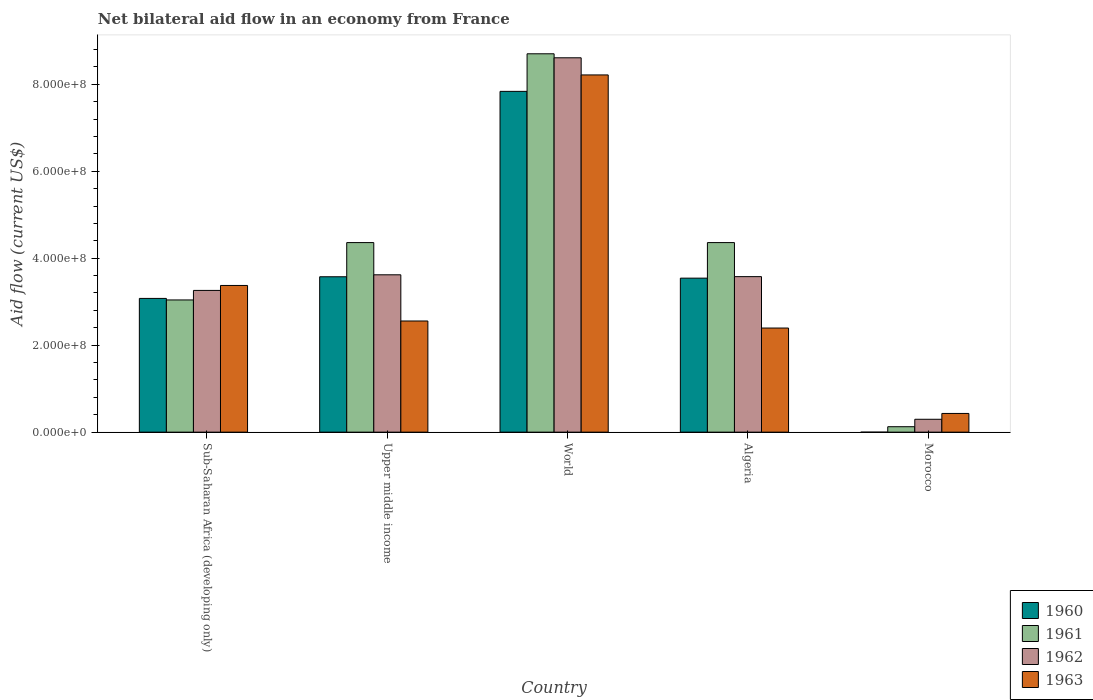How many groups of bars are there?
Offer a terse response. 5. Are the number of bars per tick equal to the number of legend labels?
Provide a short and direct response. No. Are the number of bars on each tick of the X-axis equal?
Provide a short and direct response. No. How many bars are there on the 1st tick from the left?
Provide a succinct answer. 4. How many bars are there on the 1st tick from the right?
Your answer should be compact. 3. What is the label of the 1st group of bars from the left?
Give a very brief answer. Sub-Saharan Africa (developing only). What is the net bilateral aid flow in 1960 in Morocco?
Provide a succinct answer. 0. Across all countries, what is the maximum net bilateral aid flow in 1962?
Give a very brief answer. 8.61e+08. Across all countries, what is the minimum net bilateral aid flow in 1963?
Provide a succinct answer. 4.30e+07. In which country was the net bilateral aid flow in 1960 maximum?
Offer a very short reply. World. What is the total net bilateral aid flow in 1963 in the graph?
Offer a terse response. 1.70e+09. What is the difference between the net bilateral aid flow in 1961 in Algeria and that in Upper middle income?
Give a very brief answer. 0. What is the difference between the net bilateral aid flow in 1961 in World and the net bilateral aid flow in 1960 in Algeria?
Your answer should be compact. 5.16e+08. What is the average net bilateral aid flow in 1962 per country?
Offer a very short reply. 3.87e+08. What is the difference between the net bilateral aid flow of/in 1963 and net bilateral aid flow of/in 1960 in World?
Your response must be concise. 3.78e+07. What is the ratio of the net bilateral aid flow in 1962 in Morocco to that in World?
Your answer should be very brief. 0.03. Is the net bilateral aid flow in 1963 in Algeria less than that in Morocco?
Offer a terse response. No. Is the difference between the net bilateral aid flow in 1963 in Algeria and Sub-Saharan Africa (developing only) greater than the difference between the net bilateral aid flow in 1960 in Algeria and Sub-Saharan Africa (developing only)?
Keep it short and to the point. No. What is the difference between the highest and the second highest net bilateral aid flow in 1961?
Offer a terse response. 4.34e+08. What is the difference between the highest and the lowest net bilateral aid flow in 1962?
Offer a very short reply. 8.31e+08. Is the sum of the net bilateral aid flow in 1962 in Algeria and Morocco greater than the maximum net bilateral aid flow in 1963 across all countries?
Provide a succinct answer. No. Is it the case that in every country, the sum of the net bilateral aid flow in 1963 and net bilateral aid flow in 1960 is greater than the net bilateral aid flow in 1962?
Offer a very short reply. Yes. How many bars are there?
Keep it short and to the point. 19. What is the difference between two consecutive major ticks on the Y-axis?
Your answer should be compact. 2.00e+08. Does the graph contain grids?
Ensure brevity in your answer.  No. What is the title of the graph?
Make the answer very short. Net bilateral aid flow in an economy from France. Does "1961" appear as one of the legend labels in the graph?
Your answer should be very brief. Yes. What is the label or title of the X-axis?
Ensure brevity in your answer.  Country. What is the Aid flow (current US$) in 1960 in Sub-Saharan Africa (developing only)?
Your answer should be very brief. 3.08e+08. What is the Aid flow (current US$) of 1961 in Sub-Saharan Africa (developing only)?
Your answer should be very brief. 3.04e+08. What is the Aid flow (current US$) in 1962 in Sub-Saharan Africa (developing only)?
Your answer should be very brief. 3.26e+08. What is the Aid flow (current US$) of 1963 in Sub-Saharan Africa (developing only)?
Offer a very short reply. 3.37e+08. What is the Aid flow (current US$) in 1960 in Upper middle income?
Offer a terse response. 3.57e+08. What is the Aid flow (current US$) in 1961 in Upper middle income?
Offer a terse response. 4.36e+08. What is the Aid flow (current US$) in 1962 in Upper middle income?
Offer a terse response. 3.62e+08. What is the Aid flow (current US$) in 1963 in Upper middle income?
Keep it short and to the point. 2.56e+08. What is the Aid flow (current US$) in 1960 in World?
Your response must be concise. 7.84e+08. What is the Aid flow (current US$) of 1961 in World?
Keep it short and to the point. 8.70e+08. What is the Aid flow (current US$) in 1962 in World?
Ensure brevity in your answer.  8.61e+08. What is the Aid flow (current US$) in 1963 in World?
Keep it short and to the point. 8.21e+08. What is the Aid flow (current US$) in 1960 in Algeria?
Make the answer very short. 3.54e+08. What is the Aid flow (current US$) of 1961 in Algeria?
Ensure brevity in your answer.  4.36e+08. What is the Aid flow (current US$) in 1962 in Algeria?
Offer a very short reply. 3.58e+08. What is the Aid flow (current US$) of 1963 in Algeria?
Ensure brevity in your answer.  2.39e+08. What is the Aid flow (current US$) in 1960 in Morocco?
Keep it short and to the point. 0. What is the Aid flow (current US$) of 1961 in Morocco?
Provide a succinct answer. 1.25e+07. What is the Aid flow (current US$) of 1962 in Morocco?
Offer a terse response. 2.96e+07. What is the Aid flow (current US$) of 1963 in Morocco?
Give a very brief answer. 4.30e+07. Across all countries, what is the maximum Aid flow (current US$) of 1960?
Give a very brief answer. 7.84e+08. Across all countries, what is the maximum Aid flow (current US$) of 1961?
Ensure brevity in your answer.  8.70e+08. Across all countries, what is the maximum Aid flow (current US$) of 1962?
Ensure brevity in your answer.  8.61e+08. Across all countries, what is the maximum Aid flow (current US$) in 1963?
Provide a succinct answer. 8.21e+08. Across all countries, what is the minimum Aid flow (current US$) of 1960?
Keep it short and to the point. 0. Across all countries, what is the minimum Aid flow (current US$) of 1961?
Your response must be concise. 1.25e+07. Across all countries, what is the minimum Aid flow (current US$) of 1962?
Keep it short and to the point. 2.96e+07. Across all countries, what is the minimum Aid flow (current US$) of 1963?
Your answer should be very brief. 4.30e+07. What is the total Aid flow (current US$) in 1960 in the graph?
Keep it short and to the point. 1.80e+09. What is the total Aid flow (current US$) in 1961 in the graph?
Make the answer very short. 2.06e+09. What is the total Aid flow (current US$) of 1962 in the graph?
Your response must be concise. 1.94e+09. What is the total Aid flow (current US$) in 1963 in the graph?
Make the answer very short. 1.70e+09. What is the difference between the Aid flow (current US$) of 1960 in Sub-Saharan Africa (developing only) and that in Upper middle income?
Keep it short and to the point. -4.98e+07. What is the difference between the Aid flow (current US$) of 1961 in Sub-Saharan Africa (developing only) and that in Upper middle income?
Your answer should be compact. -1.32e+08. What is the difference between the Aid flow (current US$) of 1962 in Sub-Saharan Africa (developing only) and that in Upper middle income?
Ensure brevity in your answer.  -3.59e+07. What is the difference between the Aid flow (current US$) in 1963 in Sub-Saharan Africa (developing only) and that in Upper middle income?
Your answer should be very brief. 8.17e+07. What is the difference between the Aid flow (current US$) of 1960 in Sub-Saharan Africa (developing only) and that in World?
Offer a terse response. -4.76e+08. What is the difference between the Aid flow (current US$) in 1961 in Sub-Saharan Africa (developing only) and that in World?
Give a very brief answer. -5.66e+08. What is the difference between the Aid flow (current US$) of 1962 in Sub-Saharan Africa (developing only) and that in World?
Your answer should be compact. -5.35e+08. What is the difference between the Aid flow (current US$) of 1963 in Sub-Saharan Africa (developing only) and that in World?
Keep it short and to the point. -4.84e+08. What is the difference between the Aid flow (current US$) in 1960 in Sub-Saharan Africa (developing only) and that in Algeria?
Offer a terse response. -4.66e+07. What is the difference between the Aid flow (current US$) in 1961 in Sub-Saharan Africa (developing only) and that in Algeria?
Ensure brevity in your answer.  -1.32e+08. What is the difference between the Aid flow (current US$) of 1962 in Sub-Saharan Africa (developing only) and that in Algeria?
Your answer should be very brief. -3.17e+07. What is the difference between the Aid flow (current US$) of 1963 in Sub-Saharan Africa (developing only) and that in Algeria?
Your answer should be very brief. 9.79e+07. What is the difference between the Aid flow (current US$) of 1961 in Sub-Saharan Africa (developing only) and that in Morocco?
Your response must be concise. 2.92e+08. What is the difference between the Aid flow (current US$) of 1962 in Sub-Saharan Africa (developing only) and that in Morocco?
Make the answer very short. 2.96e+08. What is the difference between the Aid flow (current US$) in 1963 in Sub-Saharan Africa (developing only) and that in Morocco?
Keep it short and to the point. 2.94e+08. What is the difference between the Aid flow (current US$) of 1960 in Upper middle income and that in World?
Your response must be concise. -4.26e+08. What is the difference between the Aid flow (current US$) of 1961 in Upper middle income and that in World?
Your response must be concise. -4.34e+08. What is the difference between the Aid flow (current US$) in 1962 in Upper middle income and that in World?
Offer a terse response. -4.99e+08. What is the difference between the Aid flow (current US$) of 1963 in Upper middle income and that in World?
Offer a terse response. -5.66e+08. What is the difference between the Aid flow (current US$) in 1960 in Upper middle income and that in Algeria?
Give a very brief answer. 3.20e+06. What is the difference between the Aid flow (current US$) of 1961 in Upper middle income and that in Algeria?
Your answer should be very brief. 0. What is the difference between the Aid flow (current US$) in 1962 in Upper middle income and that in Algeria?
Your answer should be compact. 4.20e+06. What is the difference between the Aid flow (current US$) in 1963 in Upper middle income and that in Algeria?
Offer a terse response. 1.62e+07. What is the difference between the Aid flow (current US$) in 1961 in Upper middle income and that in Morocco?
Ensure brevity in your answer.  4.23e+08. What is the difference between the Aid flow (current US$) in 1962 in Upper middle income and that in Morocco?
Give a very brief answer. 3.32e+08. What is the difference between the Aid flow (current US$) in 1963 in Upper middle income and that in Morocco?
Provide a short and direct response. 2.13e+08. What is the difference between the Aid flow (current US$) in 1960 in World and that in Algeria?
Make the answer very short. 4.30e+08. What is the difference between the Aid flow (current US$) in 1961 in World and that in Algeria?
Your response must be concise. 4.34e+08. What is the difference between the Aid flow (current US$) of 1962 in World and that in Algeria?
Give a very brief answer. 5.03e+08. What is the difference between the Aid flow (current US$) in 1963 in World and that in Algeria?
Make the answer very short. 5.82e+08. What is the difference between the Aid flow (current US$) of 1961 in World and that in Morocco?
Offer a very short reply. 8.58e+08. What is the difference between the Aid flow (current US$) of 1962 in World and that in Morocco?
Your response must be concise. 8.31e+08. What is the difference between the Aid flow (current US$) in 1963 in World and that in Morocco?
Keep it short and to the point. 7.78e+08. What is the difference between the Aid flow (current US$) of 1961 in Algeria and that in Morocco?
Make the answer very short. 4.23e+08. What is the difference between the Aid flow (current US$) in 1962 in Algeria and that in Morocco?
Keep it short and to the point. 3.28e+08. What is the difference between the Aid flow (current US$) in 1963 in Algeria and that in Morocco?
Give a very brief answer. 1.96e+08. What is the difference between the Aid flow (current US$) in 1960 in Sub-Saharan Africa (developing only) and the Aid flow (current US$) in 1961 in Upper middle income?
Ensure brevity in your answer.  -1.28e+08. What is the difference between the Aid flow (current US$) in 1960 in Sub-Saharan Africa (developing only) and the Aid flow (current US$) in 1962 in Upper middle income?
Give a very brief answer. -5.43e+07. What is the difference between the Aid flow (current US$) in 1960 in Sub-Saharan Africa (developing only) and the Aid flow (current US$) in 1963 in Upper middle income?
Your answer should be very brief. 5.19e+07. What is the difference between the Aid flow (current US$) in 1961 in Sub-Saharan Africa (developing only) and the Aid flow (current US$) in 1962 in Upper middle income?
Ensure brevity in your answer.  -5.78e+07. What is the difference between the Aid flow (current US$) of 1961 in Sub-Saharan Africa (developing only) and the Aid flow (current US$) of 1963 in Upper middle income?
Keep it short and to the point. 4.84e+07. What is the difference between the Aid flow (current US$) of 1962 in Sub-Saharan Africa (developing only) and the Aid flow (current US$) of 1963 in Upper middle income?
Provide a succinct answer. 7.03e+07. What is the difference between the Aid flow (current US$) of 1960 in Sub-Saharan Africa (developing only) and the Aid flow (current US$) of 1961 in World?
Offer a very short reply. -5.62e+08. What is the difference between the Aid flow (current US$) in 1960 in Sub-Saharan Africa (developing only) and the Aid flow (current US$) in 1962 in World?
Give a very brief answer. -5.53e+08. What is the difference between the Aid flow (current US$) in 1960 in Sub-Saharan Africa (developing only) and the Aid flow (current US$) in 1963 in World?
Give a very brief answer. -5.14e+08. What is the difference between the Aid flow (current US$) in 1961 in Sub-Saharan Africa (developing only) and the Aid flow (current US$) in 1962 in World?
Give a very brief answer. -5.57e+08. What is the difference between the Aid flow (current US$) in 1961 in Sub-Saharan Africa (developing only) and the Aid flow (current US$) in 1963 in World?
Make the answer very short. -5.17e+08. What is the difference between the Aid flow (current US$) of 1962 in Sub-Saharan Africa (developing only) and the Aid flow (current US$) of 1963 in World?
Make the answer very short. -4.96e+08. What is the difference between the Aid flow (current US$) of 1960 in Sub-Saharan Africa (developing only) and the Aid flow (current US$) of 1961 in Algeria?
Your answer should be compact. -1.28e+08. What is the difference between the Aid flow (current US$) in 1960 in Sub-Saharan Africa (developing only) and the Aid flow (current US$) in 1962 in Algeria?
Your answer should be compact. -5.01e+07. What is the difference between the Aid flow (current US$) of 1960 in Sub-Saharan Africa (developing only) and the Aid flow (current US$) of 1963 in Algeria?
Your answer should be compact. 6.81e+07. What is the difference between the Aid flow (current US$) in 1961 in Sub-Saharan Africa (developing only) and the Aid flow (current US$) in 1962 in Algeria?
Offer a very short reply. -5.36e+07. What is the difference between the Aid flow (current US$) in 1961 in Sub-Saharan Africa (developing only) and the Aid flow (current US$) in 1963 in Algeria?
Ensure brevity in your answer.  6.46e+07. What is the difference between the Aid flow (current US$) in 1962 in Sub-Saharan Africa (developing only) and the Aid flow (current US$) in 1963 in Algeria?
Offer a terse response. 8.65e+07. What is the difference between the Aid flow (current US$) in 1960 in Sub-Saharan Africa (developing only) and the Aid flow (current US$) in 1961 in Morocco?
Ensure brevity in your answer.  2.95e+08. What is the difference between the Aid flow (current US$) in 1960 in Sub-Saharan Africa (developing only) and the Aid flow (current US$) in 1962 in Morocco?
Your answer should be compact. 2.78e+08. What is the difference between the Aid flow (current US$) of 1960 in Sub-Saharan Africa (developing only) and the Aid flow (current US$) of 1963 in Morocco?
Make the answer very short. 2.64e+08. What is the difference between the Aid flow (current US$) of 1961 in Sub-Saharan Africa (developing only) and the Aid flow (current US$) of 1962 in Morocco?
Provide a succinct answer. 2.74e+08. What is the difference between the Aid flow (current US$) of 1961 in Sub-Saharan Africa (developing only) and the Aid flow (current US$) of 1963 in Morocco?
Your answer should be very brief. 2.61e+08. What is the difference between the Aid flow (current US$) of 1962 in Sub-Saharan Africa (developing only) and the Aid flow (current US$) of 1963 in Morocco?
Provide a short and direct response. 2.83e+08. What is the difference between the Aid flow (current US$) in 1960 in Upper middle income and the Aid flow (current US$) in 1961 in World?
Give a very brief answer. -5.13e+08. What is the difference between the Aid flow (current US$) in 1960 in Upper middle income and the Aid flow (current US$) in 1962 in World?
Offer a very short reply. -5.04e+08. What is the difference between the Aid flow (current US$) of 1960 in Upper middle income and the Aid flow (current US$) of 1963 in World?
Give a very brief answer. -4.64e+08. What is the difference between the Aid flow (current US$) in 1961 in Upper middle income and the Aid flow (current US$) in 1962 in World?
Your answer should be compact. -4.25e+08. What is the difference between the Aid flow (current US$) of 1961 in Upper middle income and the Aid flow (current US$) of 1963 in World?
Make the answer very short. -3.86e+08. What is the difference between the Aid flow (current US$) in 1962 in Upper middle income and the Aid flow (current US$) in 1963 in World?
Offer a terse response. -4.60e+08. What is the difference between the Aid flow (current US$) in 1960 in Upper middle income and the Aid flow (current US$) in 1961 in Algeria?
Provide a succinct answer. -7.86e+07. What is the difference between the Aid flow (current US$) in 1960 in Upper middle income and the Aid flow (current US$) in 1963 in Algeria?
Ensure brevity in your answer.  1.18e+08. What is the difference between the Aid flow (current US$) in 1961 in Upper middle income and the Aid flow (current US$) in 1962 in Algeria?
Offer a very short reply. 7.83e+07. What is the difference between the Aid flow (current US$) of 1961 in Upper middle income and the Aid flow (current US$) of 1963 in Algeria?
Make the answer very short. 1.96e+08. What is the difference between the Aid flow (current US$) in 1962 in Upper middle income and the Aid flow (current US$) in 1963 in Algeria?
Offer a very short reply. 1.22e+08. What is the difference between the Aid flow (current US$) in 1960 in Upper middle income and the Aid flow (current US$) in 1961 in Morocco?
Offer a terse response. 3.45e+08. What is the difference between the Aid flow (current US$) of 1960 in Upper middle income and the Aid flow (current US$) of 1962 in Morocco?
Your response must be concise. 3.28e+08. What is the difference between the Aid flow (current US$) in 1960 in Upper middle income and the Aid flow (current US$) in 1963 in Morocco?
Your answer should be very brief. 3.14e+08. What is the difference between the Aid flow (current US$) in 1961 in Upper middle income and the Aid flow (current US$) in 1962 in Morocco?
Provide a short and direct response. 4.06e+08. What is the difference between the Aid flow (current US$) in 1961 in Upper middle income and the Aid flow (current US$) in 1963 in Morocco?
Keep it short and to the point. 3.93e+08. What is the difference between the Aid flow (current US$) in 1962 in Upper middle income and the Aid flow (current US$) in 1963 in Morocco?
Provide a short and direct response. 3.19e+08. What is the difference between the Aid flow (current US$) of 1960 in World and the Aid flow (current US$) of 1961 in Algeria?
Make the answer very short. 3.48e+08. What is the difference between the Aid flow (current US$) in 1960 in World and the Aid flow (current US$) in 1962 in Algeria?
Ensure brevity in your answer.  4.26e+08. What is the difference between the Aid flow (current US$) of 1960 in World and the Aid flow (current US$) of 1963 in Algeria?
Ensure brevity in your answer.  5.44e+08. What is the difference between the Aid flow (current US$) of 1961 in World and the Aid flow (current US$) of 1962 in Algeria?
Your answer should be compact. 5.12e+08. What is the difference between the Aid flow (current US$) of 1961 in World and the Aid flow (current US$) of 1963 in Algeria?
Make the answer very short. 6.31e+08. What is the difference between the Aid flow (current US$) in 1962 in World and the Aid flow (current US$) in 1963 in Algeria?
Provide a short and direct response. 6.21e+08. What is the difference between the Aid flow (current US$) in 1960 in World and the Aid flow (current US$) in 1961 in Morocco?
Your answer should be compact. 7.71e+08. What is the difference between the Aid flow (current US$) in 1960 in World and the Aid flow (current US$) in 1962 in Morocco?
Your response must be concise. 7.54e+08. What is the difference between the Aid flow (current US$) of 1960 in World and the Aid flow (current US$) of 1963 in Morocco?
Provide a short and direct response. 7.41e+08. What is the difference between the Aid flow (current US$) in 1961 in World and the Aid flow (current US$) in 1962 in Morocco?
Your answer should be compact. 8.40e+08. What is the difference between the Aid flow (current US$) of 1961 in World and the Aid flow (current US$) of 1963 in Morocco?
Offer a very short reply. 8.27e+08. What is the difference between the Aid flow (current US$) of 1962 in World and the Aid flow (current US$) of 1963 in Morocco?
Offer a terse response. 8.18e+08. What is the difference between the Aid flow (current US$) in 1960 in Algeria and the Aid flow (current US$) in 1961 in Morocco?
Ensure brevity in your answer.  3.42e+08. What is the difference between the Aid flow (current US$) of 1960 in Algeria and the Aid flow (current US$) of 1962 in Morocco?
Offer a very short reply. 3.24e+08. What is the difference between the Aid flow (current US$) in 1960 in Algeria and the Aid flow (current US$) in 1963 in Morocco?
Provide a short and direct response. 3.11e+08. What is the difference between the Aid flow (current US$) of 1961 in Algeria and the Aid flow (current US$) of 1962 in Morocco?
Provide a succinct answer. 4.06e+08. What is the difference between the Aid flow (current US$) of 1961 in Algeria and the Aid flow (current US$) of 1963 in Morocco?
Keep it short and to the point. 3.93e+08. What is the difference between the Aid flow (current US$) in 1962 in Algeria and the Aid flow (current US$) in 1963 in Morocco?
Give a very brief answer. 3.15e+08. What is the average Aid flow (current US$) of 1960 per country?
Offer a very short reply. 3.60e+08. What is the average Aid flow (current US$) of 1961 per country?
Keep it short and to the point. 4.12e+08. What is the average Aid flow (current US$) in 1962 per country?
Your response must be concise. 3.87e+08. What is the average Aid flow (current US$) of 1963 per country?
Give a very brief answer. 3.39e+08. What is the difference between the Aid flow (current US$) in 1960 and Aid flow (current US$) in 1961 in Sub-Saharan Africa (developing only)?
Ensure brevity in your answer.  3.50e+06. What is the difference between the Aid flow (current US$) in 1960 and Aid flow (current US$) in 1962 in Sub-Saharan Africa (developing only)?
Your response must be concise. -1.84e+07. What is the difference between the Aid flow (current US$) in 1960 and Aid flow (current US$) in 1963 in Sub-Saharan Africa (developing only)?
Provide a short and direct response. -2.98e+07. What is the difference between the Aid flow (current US$) in 1961 and Aid flow (current US$) in 1962 in Sub-Saharan Africa (developing only)?
Ensure brevity in your answer.  -2.19e+07. What is the difference between the Aid flow (current US$) in 1961 and Aid flow (current US$) in 1963 in Sub-Saharan Africa (developing only)?
Offer a terse response. -3.33e+07. What is the difference between the Aid flow (current US$) in 1962 and Aid flow (current US$) in 1963 in Sub-Saharan Africa (developing only)?
Provide a succinct answer. -1.14e+07. What is the difference between the Aid flow (current US$) in 1960 and Aid flow (current US$) in 1961 in Upper middle income?
Your response must be concise. -7.86e+07. What is the difference between the Aid flow (current US$) of 1960 and Aid flow (current US$) of 1962 in Upper middle income?
Give a very brief answer. -4.50e+06. What is the difference between the Aid flow (current US$) in 1960 and Aid flow (current US$) in 1963 in Upper middle income?
Your answer should be compact. 1.02e+08. What is the difference between the Aid flow (current US$) in 1961 and Aid flow (current US$) in 1962 in Upper middle income?
Your answer should be very brief. 7.41e+07. What is the difference between the Aid flow (current US$) in 1961 and Aid flow (current US$) in 1963 in Upper middle income?
Your response must be concise. 1.80e+08. What is the difference between the Aid flow (current US$) in 1962 and Aid flow (current US$) in 1963 in Upper middle income?
Offer a very short reply. 1.06e+08. What is the difference between the Aid flow (current US$) in 1960 and Aid flow (current US$) in 1961 in World?
Provide a succinct answer. -8.64e+07. What is the difference between the Aid flow (current US$) of 1960 and Aid flow (current US$) of 1962 in World?
Ensure brevity in your answer.  -7.72e+07. What is the difference between the Aid flow (current US$) of 1960 and Aid flow (current US$) of 1963 in World?
Your response must be concise. -3.78e+07. What is the difference between the Aid flow (current US$) in 1961 and Aid flow (current US$) in 1962 in World?
Ensure brevity in your answer.  9.20e+06. What is the difference between the Aid flow (current US$) in 1961 and Aid flow (current US$) in 1963 in World?
Offer a terse response. 4.86e+07. What is the difference between the Aid flow (current US$) of 1962 and Aid flow (current US$) of 1963 in World?
Offer a very short reply. 3.94e+07. What is the difference between the Aid flow (current US$) in 1960 and Aid flow (current US$) in 1961 in Algeria?
Your answer should be compact. -8.18e+07. What is the difference between the Aid flow (current US$) of 1960 and Aid flow (current US$) of 1962 in Algeria?
Offer a terse response. -3.50e+06. What is the difference between the Aid flow (current US$) of 1960 and Aid flow (current US$) of 1963 in Algeria?
Offer a very short reply. 1.15e+08. What is the difference between the Aid flow (current US$) in 1961 and Aid flow (current US$) in 1962 in Algeria?
Ensure brevity in your answer.  7.83e+07. What is the difference between the Aid flow (current US$) of 1961 and Aid flow (current US$) of 1963 in Algeria?
Give a very brief answer. 1.96e+08. What is the difference between the Aid flow (current US$) of 1962 and Aid flow (current US$) of 1963 in Algeria?
Your answer should be very brief. 1.18e+08. What is the difference between the Aid flow (current US$) in 1961 and Aid flow (current US$) in 1962 in Morocco?
Your answer should be very brief. -1.71e+07. What is the difference between the Aid flow (current US$) of 1961 and Aid flow (current US$) of 1963 in Morocco?
Keep it short and to the point. -3.05e+07. What is the difference between the Aid flow (current US$) in 1962 and Aid flow (current US$) in 1963 in Morocco?
Provide a short and direct response. -1.34e+07. What is the ratio of the Aid flow (current US$) of 1960 in Sub-Saharan Africa (developing only) to that in Upper middle income?
Your answer should be very brief. 0.86. What is the ratio of the Aid flow (current US$) of 1961 in Sub-Saharan Africa (developing only) to that in Upper middle income?
Keep it short and to the point. 0.7. What is the ratio of the Aid flow (current US$) of 1962 in Sub-Saharan Africa (developing only) to that in Upper middle income?
Ensure brevity in your answer.  0.9. What is the ratio of the Aid flow (current US$) in 1963 in Sub-Saharan Africa (developing only) to that in Upper middle income?
Your response must be concise. 1.32. What is the ratio of the Aid flow (current US$) of 1960 in Sub-Saharan Africa (developing only) to that in World?
Offer a terse response. 0.39. What is the ratio of the Aid flow (current US$) in 1961 in Sub-Saharan Africa (developing only) to that in World?
Your response must be concise. 0.35. What is the ratio of the Aid flow (current US$) in 1962 in Sub-Saharan Africa (developing only) to that in World?
Ensure brevity in your answer.  0.38. What is the ratio of the Aid flow (current US$) in 1963 in Sub-Saharan Africa (developing only) to that in World?
Provide a succinct answer. 0.41. What is the ratio of the Aid flow (current US$) in 1960 in Sub-Saharan Africa (developing only) to that in Algeria?
Offer a very short reply. 0.87. What is the ratio of the Aid flow (current US$) in 1961 in Sub-Saharan Africa (developing only) to that in Algeria?
Your answer should be compact. 0.7. What is the ratio of the Aid flow (current US$) in 1962 in Sub-Saharan Africa (developing only) to that in Algeria?
Offer a very short reply. 0.91. What is the ratio of the Aid flow (current US$) in 1963 in Sub-Saharan Africa (developing only) to that in Algeria?
Provide a short and direct response. 1.41. What is the ratio of the Aid flow (current US$) of 1961 in Sub-Saharan Africa (developing only) to that in Morocco?
Offer a very short reply. 24.32. What is the ratio of the Aid flow (current US$) of 1962 in Sub-Saharan Africa (developing only) to that in Morocco?
Give a very brief answer. 11.01. What is the ratio of the Aid flow (current US$) of 1963 in Sub-Saharan Africa (developing only) to that in Morocco?
Keep it short and to the point. 7.84. What is the ratio of the Aid flow (current US$) of 1960 in Upper middle income to that in World?
Offer a terse response. 0.46. What is the ratio of the Aid flow (current US$) of 1961 in Upper middle income to that in World?
Your answer should be compact. 0.5. What is the ratio of the Aid flow (current US$) in 1962 in Upper middle income to that in World?
Give a very brief answer. 0.42. What is the ratio of the Aid flow (current US$) of 1963 in Upper middle income to that in World?
Your response must be concise. 0.31. What is the ratio of the Aid flow (current US$) in 1962 in Upper middle income to that in Algeria?
Keep it short and to the point. 1.01. What is the ratio of the Aid flow (current US$) in 1963 in Upper middle income to that in Algeria?
Your answer should be compact. 1.07. What is the ratio of the Aid flow (current US$) in 1961 in Upper middle income to that in Morocco?
Ensure brevity in your answer.  34.87. What is the ratio of the Aid flow (current US$) of 1962 in Upper middle income to that in Morocco?
Your response must be concise. 12.22. What is the ratio of the Aid flow (current US$) in 1963 in Upper middle income to that in Morocco?
Keep it short and to the point. 5.94. What is the ratio of the Aid flow (current US$) in 1960 in World to that in Algeria?
Offer a terse response. 2.21. What is the ratio of the Aid flow (current US$) of 1961 in World to that in Algeria?
Make the answer very short. 2. What is the ratio of the Aid flow (current US$) in 1962 in World to that in Algeria?
Offer a terse response. 2.41. What is the ratio of the Aid flow (current US$) in 1963 in World to that in Algeria?
Ensure brevity in your answer.  3.43. What is the ratio of the Aid flow (current US$) in 1961 in World to that in Morocco?
Ensure brevity in your answer.  69.6. What is the ratio of the Aid flow (current US$) in 1962 in World to that in Morocco?
Give a very brief answer. 29.08. What is the ratio of the Aid flow (current US$) of 1963 in World to that in Morocco?
Your response must be concise. 19.1. What is the ratio of the Aid flow (current US$) in 1961 in Algeria to that in Morocco?
Keep it short and to the point. 34.87. What is the ratio of the Aid flow (current US$) in 1962 in Algeria to that in Morocco?
Provide a short and direct response. 12.08. What is the ratio of the Aid flow (current US$) of 1963 in Algeria to that in Morocco?
Provide a succinct answer. 5.57. What is the difference between the highest and the second highest Aid flow (current US$) in 1960?
Offer a very short reply. 4.26e+08. What is the difference between the highest and the second highest Aid flow (current US$) of 1961?
Make the answer very short. 4.34e+08. What is the difference between the highest and the second highest Aid flow (current US$) of 1962?
Give a very brief answer. 4.99e+08. What is the difference between the highest and the second highest Aid flow (current US$) of 1963?
Keep it short and to the point. 4.84e+08. What is the difference between the highest and the lowest Aid flow (current US$) of 1960?
Ensure brevity in your answer.  7.84e+08. What is the difference between the highest and the lowest Aid flow (current US$) of 1961?
Your answer should be compact. 8.58e+08. What is the difference between the highest and the lowest Aid flow (current US$) in 1962?
Keep it short and to the point. 8.31e+08. What is the difference between the highest and the lowest Aid flow (current US$) in 1963?
Your response must be concise. 7.78e+08. 